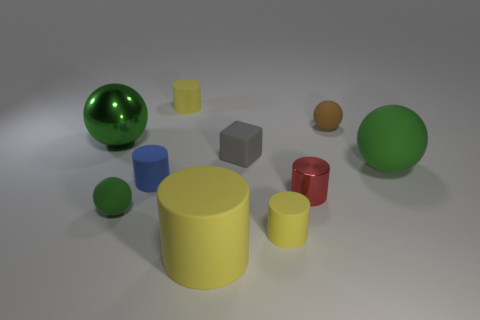Subtract all yellow cylinders. How many were subtracted if there are1yellow cylinders left? 2 Subtract all gray blocks. How many green spheres are left? 3 Subtract 2 cylinders. How many cylinders are left? 3 Subtract all big cylinders. How many cylinders are left? 4 Subtract all red cylinders. How many cylinders are left? 4 Subtract all cyan cylinders. Subtract all yellow spheres. How many cylinders are left? 5 Subtract all cubes. How many objects are left? 9 Subtract all large blue matte spheres. Subtract all tiny balls. How many objects are left? 8 Add 8 small gray objects. How many small gray objects are left? 9 Add 1 big red metallic objects. How many big red metallic objects exist? 1 